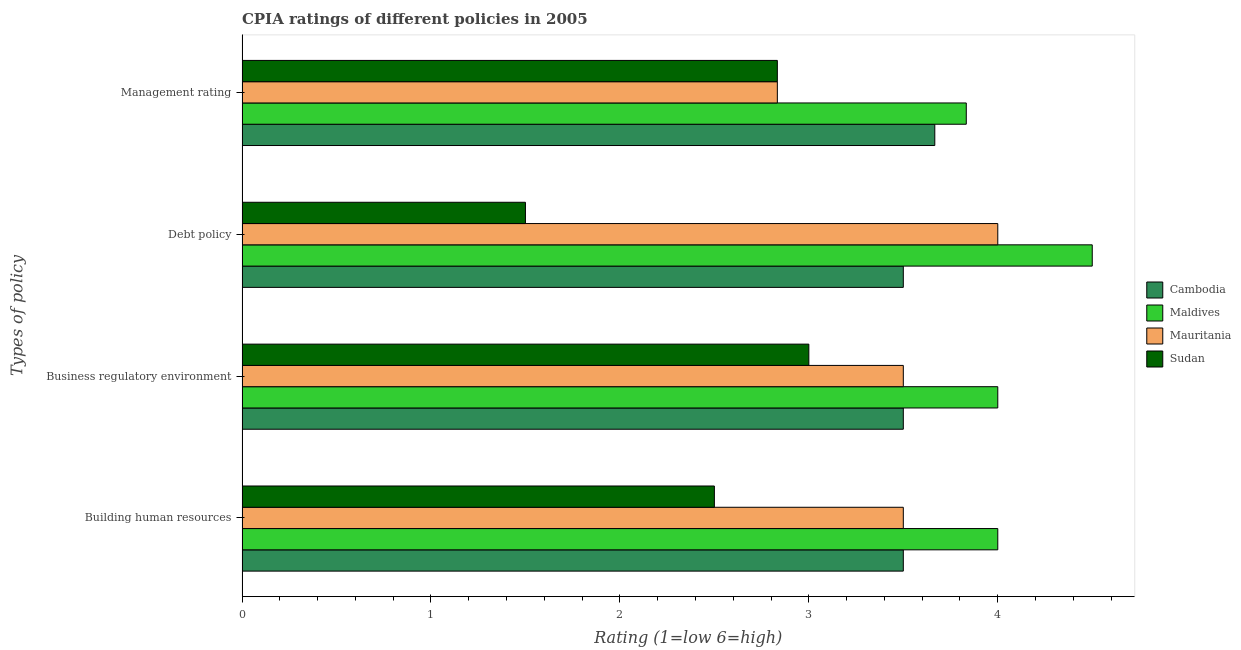How many bars are there on the 3rd tick from the top?
Offer a terse response. 4. What is the label of the 2nd group of bars from the top?
Make the answer very short. Debt policy. What is the cpia rating of building human resources in Cambodia?
Offer a terse response. 3.5. Across all countries, what is the maximum cpia rating of building human resources?
Offer a very short reply. 4. Across all countries, what is the minimum cpia rating of management?
Keep it short and to the point. 2.83. In which country was the cpia rating of debt policy maximum?
Your response must be concise. Maldives. In which country was the cpia rating of business regulatory environment minimum?
Give a very brief answer. Sudan. What is the total cpia rating of building human resources in the graph?
Your answer should be compact. 13.5. What is the difference between the cpia rating of debt policy in Sudan and the cpia rating of management in Mauritania?
Ensure brevity in your answer.  -1.33. What is the average cpia rating of business regulatory environment per country?
Offer a very short reply. 3.5. What is the difference between the cpia rating of business regulatory environment and cpia rating of management in Cambodia?
Your answer should be compact. -0.17. What is the difference between the highest and the second highest cpia rating of management?
Your response must be concise. 0.17. In how many countries, is the cpia rating of debt policy greater than the average cpia rating of debt policy taken over all countries?
Offer a terse response. 3. Is the sum of the cpia rating of management in Cambodia and Sudan greater than the maximum cpia rating of debt policy across all countries?
Your answer should be very brief. Yes. Is it the case that in every country, the sum of the cpia rating of business regulatory environment and cpia rating of management is greater than the sum of cpia rating of building human resources and cpia rating of debt policy?
Offer a very short reply. No. What does the 1st bar from the top in Business regulatory environment represents?
Your answer should be compact. Sudan. What does the 3rd bar from the bottom in Building human resources represents?
Your response must be concise. Mauritania. How many bars are there?
Ensure brevity in your answer.  16. Are the values on the major ticks of X-axis written in scientific E-notation?
Offer a very short reply. No. Does the graph contain any zero values?
Keep it short and to the point. No. How many legend labels are there?
Your answer should be compact. 4. What is the title of the graph?
Your answer should be very brief. CPIA ratings of different policies in 2005. Does "Yemen, Rep." appear as one of the legend labels in the graph?
Ensure brevity in your answer.  No. What is the label or title of the X-axis?
Provide a short and direct response. Rating (1=low 6=high). What is the label or title of the Y-axis?
Your response must be concise. Types of policy. What is the Rating (1=low 6=high) in Cambodia in Building human resources?
Ensure brevity in your answer.  3.5. What is the Rating (1=low 6=high) of Sudan in Building human resources?
Provide a short and direct response. 2.5. What is the Rating (1=low 6=high) of Cambodia in Business regulatory environment?
Your response must be concise. 3.5. What is the Rating (1=low 6=high) in Mauritania in Business regulatory environment?
Make the answer very short. 3.5. What is the Rating (1=low 6=high) in Cambodia in Debt policy?
Offer a very short reply. 3.5. What is the Rating (1=low 6=high) of Maldives in Debt policy?
Offer a very short reply. 4.5. What is the Rating (1=low 6=high) of Mauritania in Debt policy?
Make the answer very short. 4. What is the Rating (1=low 6=high) in Cambodia in Management rating?
Make the answer very short. 3.67. What is the Rating (1=low 6=high) in Maldives in Management rating?
Your answer should be compact. 3.83. What is the Rating (1=low 6=high) in Mauritania in Management rating?
Your answer should be compact. 2.83. What is the Rating (1=low 6=high) of Sudan in Management rating?
Provide a short and direct response. 2.83. Across all Types of policy, what is the maximum Rating (1=low 6=high) of Cambodia?
Provide a short and direct response. 3.67. Across all Types of policy, what is the maximum Rating (1=low 6=high) of Maldives?
Your answer should be very brief. 4.5. Across all Types of policy, what is the maximum Rating (1=low 6=high) in Mauritania?
Your answer should be compact. 4. Across all Types of policy, what is the minimum Rating (1=low 6=high) of Maldives?
Keep it short and to the point. 3.83. Across all Types of policy, what is the minimum Rating (1=low 6=high) in Mauritania?
Your answer should be compact. 2.83. Across all Types of policy, what is the minimum Rating (1=low 6=high) of Sudan?
Ensure brevity in your answer.  1.5. What is the total Rating (1=low 6=high) of Cambodia in the graph?
Your answer should be compact. 14.17. What is the total Rating (1=low 6=high) in Maldives in the graph?
Your answer should be compact. 16.33. What is the total Rating (1=low 6=high) of Mauritania in the graph?
Give a very brief answer. 13.83. What is the total Rating (1=low 6=high) of Sudan in the graph?
Ensure brevity in your answer.  9.83. What is the difference between the Rating (1=low 6=high) in Maldives in Building human resources and that in Business regulatory environment?
Keep it short and to the point. 0. What is the difference between the Rating (1=low 6=high) in Cambodia in Building human resources and that in Debt policy?
Ensure brevity in your answer.  0. What is the difference between the Rating (1=low 6=high) in Mauritania in Building human resources and that in Debt policy?
Ensure brevity in your answer.  -0.5. What is the difference between the Rating (1=low 6=high) in Cambodia in Building human resources and that in Management rating?
Your response must be concise. -0.17. What is the difference between the Rating (1=low 6=high) of Maldives in Building human resources and that in Management rating?
Offer a terse response. 0.17. What is the difference between the Rating (1=low 6=high) of Sudan in Building human resources and that in Management rating?
Provide a short and direct response. -0.33. What is the difference between the Rating (1=low 6=high) of Maldives in Business regulatory environment and that in Debt policy?
Make the answer very short. -0.5. What is the difference between the Rating (1=low 6=high) in Sudan in Business regulatory environment and that in Debt policy?
Your answer should be very brief. 1.5. What is the difference between the Rating (1=low 6=high) of Maldives in Business regulatory environment and that in Management rating?
Offer a very short reply. 0.17. What is the difference between the Rating (1=low 6=high) of Mauritania in Business regulatory environment and that in Management rating?
Your answer should be compact. 0.67. What is the difference between the Rating (1=low 6=high) of Sudan in Business regulatory environment and that in Management rating?
Offer a terse response. 0.17. What is the difference between the Rating (1=low 6=high) in Cambodia in Debt policy and that in Management rating?
Offer a very short reply. -0.17. What is the difference between the Rating (1=low 6=high) in Sudan in Debt policy and that in Management rating?
Keep it short and to the point. -1.33. What is the difference between the Rating (1=low 6=high) of Cambodia in Building human resources and the Rating (1=low 6=high) of Maldives in Business regulatory environment?
Offer a terse response. -0.5. What is the difference between the Rating (1=low 6=high) in Cambodia in Building human resources and the Rating (1=low 6=high) in Mauritania in Business regulatory environment?
Ensure brevity in your answer.  0. What is the difference between the Rating (1=low 6=high) of Cambodia in Building human resources and the Rating (1=low 6=high) of Sudan in Business regulatory environment?
Offer a very short reply. 0.5. What is the difference between the Rating (1=low 6=high) in Cambodia in Building human resources and the Rating (1=low 6=high) in Maldives in Debt policy?
Offer a terse response. -1. What is the difference between the Rating (1=low 6=high) in Cambodia in Building human resources and the Rating (1=low 6=high) in Mauritania in Debt policy?
Offer a terse response. -0.5. What is the difference between the Rating (1=low 6=high) of Cambodia in Building human resources and the Rating (1=low 6=high) of Sudan in Debt policy?
Make the answer very short. 2. What is the difference between the Rating (1=low 6=high) of Mauritania in Building human resources and the Rating (1=low 6=high) of Sudan in Debt policy?
Your answer should be compact. 2. What is the difference between the Rating (1=low 6=high) in Cambodia in Building human resources and the Rating (1=low 6=high) in Mauritania in Management rating?
Offer a terse response. 0.67. What is the difference between the Rating (1=low 6=high) in Cambodia in Building human resources and the Rating (1=low 6=high) in Sudan in Management rating?
Offer a very short reply. 0.67. What is the difference between the Rating (1=low 6=high) in Maldives in Building human resources and the Rating (1=low 6=high) in Mauritania in Management rating?
Your response must be concise. 1.17. What is the difference between the Rating (1=low 6=high) in Cambodia in Business regulatory environment and the Rating (1=low 6=high) in Maldives in Debt policy?
Ensure brevity in your answer.  -1. What is the difference between the Rating (1=low 6=high) in Cambodia in Business regulatory environment and the Rating (1=low 6=high) in Mauritania in Debt policy?
Your response must be concise. -0.5. What is the difference between the Rating (1=low 6=high) of Cambodia in Business regulatory environment and the Rating (1=low 6=high) of Sudan in Debt policy?
Ensure brevity in your answer.  2. What is the difference between the Rating (1=low 6=high) of Maldives in Business regulatory environment and the Rating (1=low 6=high) of Mauritania in Debt policy?
Ensure brevity in your answer.  0. What is the difference between the Rating (1=low 6=high) of Cambodia in Business regulatory environment and the Rating (1=low 6=high) of Sudan in Management rating?
Keep it short and to the point. 0.67. What is the difference between the Rating (1=low 6=high) of Maldives in Business regulatory environment and the Rating (1=low 6=high) of Sudan in Management rating?
Ensure brevity in your answer.  1.17. What is the difference between the Rating (1=low 6=high) of Mauritania in Business regulatory environment and the Rating (1=low 6=high) of Sudan in Management rating?
Keep it short and to the point. 0.67. What is the difference between the Rating (1=low 6=high) of Cambodia in Debt policy and the Rating (1=low 6=high) of Maldives in Management rating?
Provide a short and direct response. -0.33. What is the difference between the Rating (1=low 6=high) in Cambodia in Debt policy and the Rating (1=low 6=high) in Mauritania in Management rating?
Provide a short and direct response. 0.67. What is the difference between the Rating (1=low 6=high) of Maldives in Debt policy and the Rating (1=low 6=high) of Sudan in Management rating?
Provide a short and direct response. 1.67. What is the average Rating (1=low 6=high) in Cambodia per Types of policy?
Ensure brevity in your answer.  3.54. What is the average Rating (1=low 6=high) in Maldives per Types of policy?
Provide a succinct answer. 4.08. What is the average Rating (1=low 6=high) of Mauritania per Types of policy?
Your response must be concise. 3.46. What is the average Rating (1=low 6=high) in Sudan per Types of policy?
Keep it short and to the point. 2.46. What is the difference between the Rating (1=low 6=high) of Cambodia and Rating (1=low 6=high) of Mauritania in Building human resources?
Make the answer very short. 0. What is the difference between the Rating (1=low 6=high) of Maldives and Rating (1=low 6=high) of Mauritania in Building human resources?
Offer a terse response. 0.5. What is the difference between the Rating (1=low 6=high) of Mauritania and Rating (1=low 6=high) of Sudan in Building human resources?
Offer a terse response. 1. What is the difference between the Rating (1=low 6=high) of Cambodia and Rating (1=low 6=high) of Sudan in Business regulatory environment?
Provide a succinct answer. 0.5. What is the difference between the Rating (1=low 6=high) of Maldives and Rating (1=low 6=high) of Mauritania in Business regulatory environment?
Your answer should be very brief. 0.5. What is the difference between the Rating (1=low 6=high) in Mauritania and Rating (1=low 6=high) in Sudan in Business regulatory environment?
Offer a very short reply. 0.5. What is the difference between the Rating (1=low 6=high) of Cambodia and Rating (1=low 6=high) of Mauritania in Debt policy?
Make the answer very short. -0.5. What is the difference between the Rating (1=low 6=high) of Maldives and Rating (1=low 6=high) of Sudan in Debt policy?
Give a very brief answer. 3. What is the difference between the Rating (1=low 6=high) in Cambodia and Rating (1=low 6=high) in Mauritania in Management rating?
Ensure brevity in your answer.  0.83. What is the difference between the Rating (1=low 6=high) of Cambodia and Rating (1=low 6=high) of Sudan in Management rating?
Offer a very short reply. 0.83. What is the difference between the Rating (1=low 6=high) of Maldives and Rating (1=low 6=high) of Mauritania in Management rating?
Make the answer very short. 1. What is the difference between the Rating (1=low 6=high) in Maldives and Rating (1=low 6=high) in Sudan in Management rating?
Keep it short and to the point. 1. What is the difference between the Rating (1=low 6=high) in Mauritania and Rating (1=low 6=high) in Sudan in Management rating?
Offer a very short reply. 0. What is the ratio of the Rating (1=low 6=high) in Cambodia in Building human resources to that in Business regulatory environment?
Offer a very short reply. 1. What is the ratio of the Rating (1=low 6=high) of Maldives in Building human resources to that in Business regulatory environment?
Provide a short and direct response. 1. What is the ratio of the Rating (1=low 6=high) of Mauritania in Building human resources to that in Business regulatory environment?
Provide a succinct answer. 1. What is the ratio of the Rating (1=low 6=high) of Maldives in Building human resources to that in Debt policy?
Your answer should be very brief. 0.89. What is the ratio of the Rating (1=low 6=high) of Cambodia in Building human resources to that in Management rating?
Make the answer very short. 0.95. What is the ratio of the Rating (1=low 6=high) of Maldives in Building human resources to that in Management rating?
Your answer should be very brief. 1.04. What is the ratio of the Rating (1=low 6=high) of Mauritania in Building human resources to that in Management rating?
Make the answer very short. 1.24. What is the ratio of the Rating (1=low 6=high) in Sudan in Building human resources to that in Management rating?
Ensure brevity in your answer.  0.88. What is the ratio of the Rating (1=low 6=high) of Cambodia in Business regulatory environment to that in Debt policy?
Offer a very short reply. 1. What is the ratio of the Rating (1=low 6=high) of Mauritania in Business regulatory environment to that in Debt policy?
Your answer should be very brief. 0.88. What is the ratio of the Rating (1=low 6=high) in Cambodia in Business regulatory environment to that in Management rating?
Keep it short and to the point. 0.95. What is the ratio of the Rating (1=low 6=high) of Maldives in Business regulatory environment to that in Management rating?
Your answer should be compact. 1.04. What is the ratio of the Rating (1=low 6=high) of Mauritania in Business regulatory environment to that in Management rating?
Ensure brevity in your answer.  1.24. What is the ratio of the Rating (1=low 6=high) in Sudan in Business regulatory environment to that in Management rating?
Provide a succinct answer. 1.06. What is the ratio of the Rating (1=low 6=high) in Cambodia in Debt policy to that in Management rating?
Your answer should be compact. 0.95. What is the ratio of the Rating (1=low 6=high) in Maldives in Debt policy to that in Management rating?
Provide a short and direct response. 1.17. What is the ratio of the Rating (1=low 6=high) in Mauritania in Debt policy to that in Management rating?
Your answer should be very brief. 1.41. What is the ratio of the Rating (1=low 6=high) in Sudan in Debt policy to that in Management rating?
Your answer should be very brief. 0.53. What is the difference between the highest and the second highest Rating (1=low 6=high) in Cambodia?
Keep it short and to the point. 0.17. What is the difference between the highest and the second highest Rating (1=low 6=high) in Mauritania?
Offer a very short reply. 0.5. What is the difference between the highest and the lowest Rating (1=low 6=high) of Cambodia?
Your answer should be very brief. 0.17. What is the difference between the highest and the lowest Rating (1=low 6=high) of Maldives?
Your answer should be compact. 0.67. What is the difference between the highest and the lowest Rating (1=low 6=high) of Mauritania?
Keep it short and to the point. 1.17. What is the difference between the highest and the lowest Rating (1=low 6=high) of Sudan?
Your response must be concise. 1.5. 